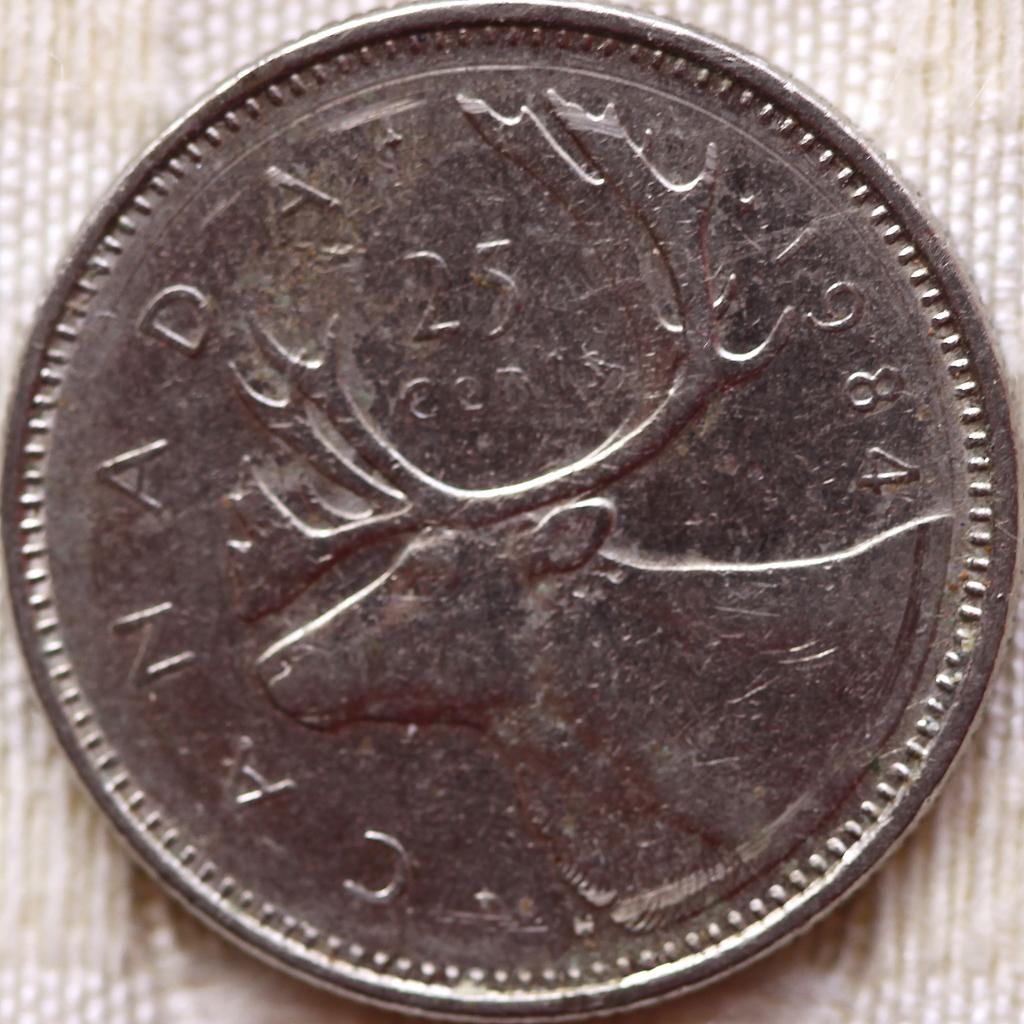<image>
Provide a brief description of the given image. Silver coin with a moose and the year 1984 on it. 